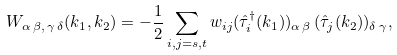Convert formula to latex. <formula><loc_0><loc_0><loc_500><loc_500>W _ { \alpha \, \beta , \, \gamma \, \delta } ( { k } _ { 1 } , { k } _ { 2 } ) = - \frac { 1 } { 2 } \sum _ { i , j = s , t } w _ { i j } ( { \hat { \tau } } ^ { \dagger } _ { i } ( { k } _ { 1 } ) ) _ { \alpha \, \beta } \, ( { \hat { \tau } } _ { j } ( { k } _ { 2 } ) ) _ { \delta \, \gamma } ,</formula> 